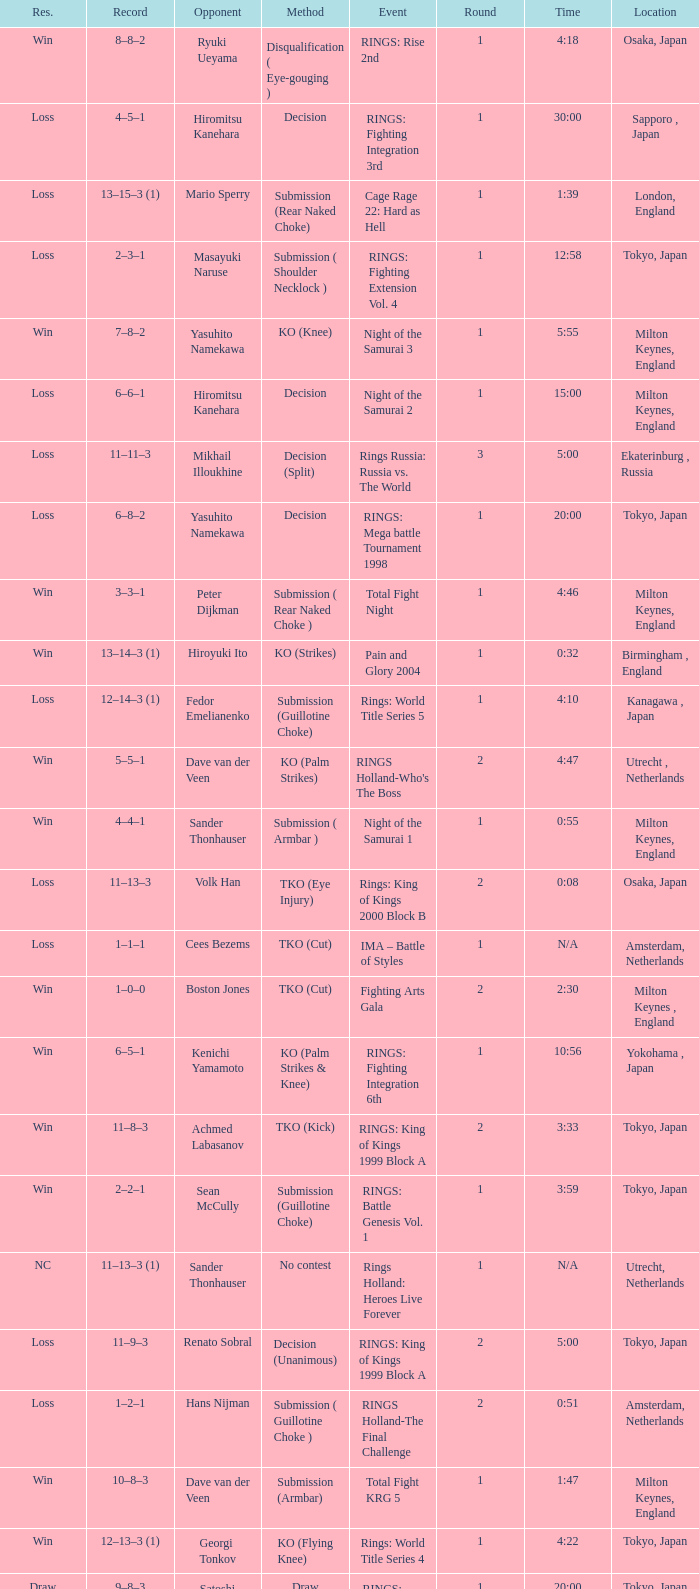What was the method for opponent of Ivan Serati? Submission (Rear Naked Choke). 